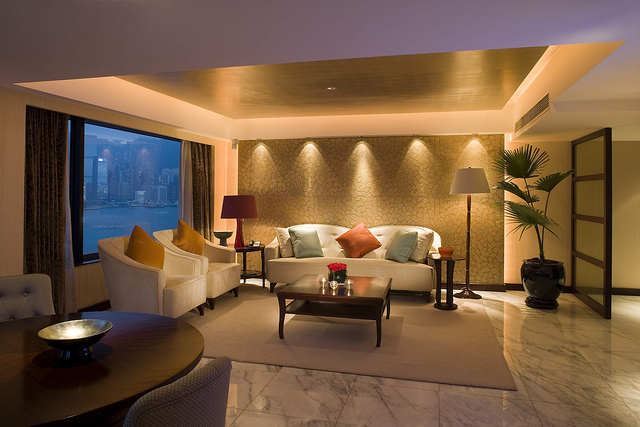<image>Where is the house located? The location of the house is unknown. It may be located in New York, California, underwater, or near water. Where is the house located? It is unclear where the house is located. It can be seen near water or in a city. 